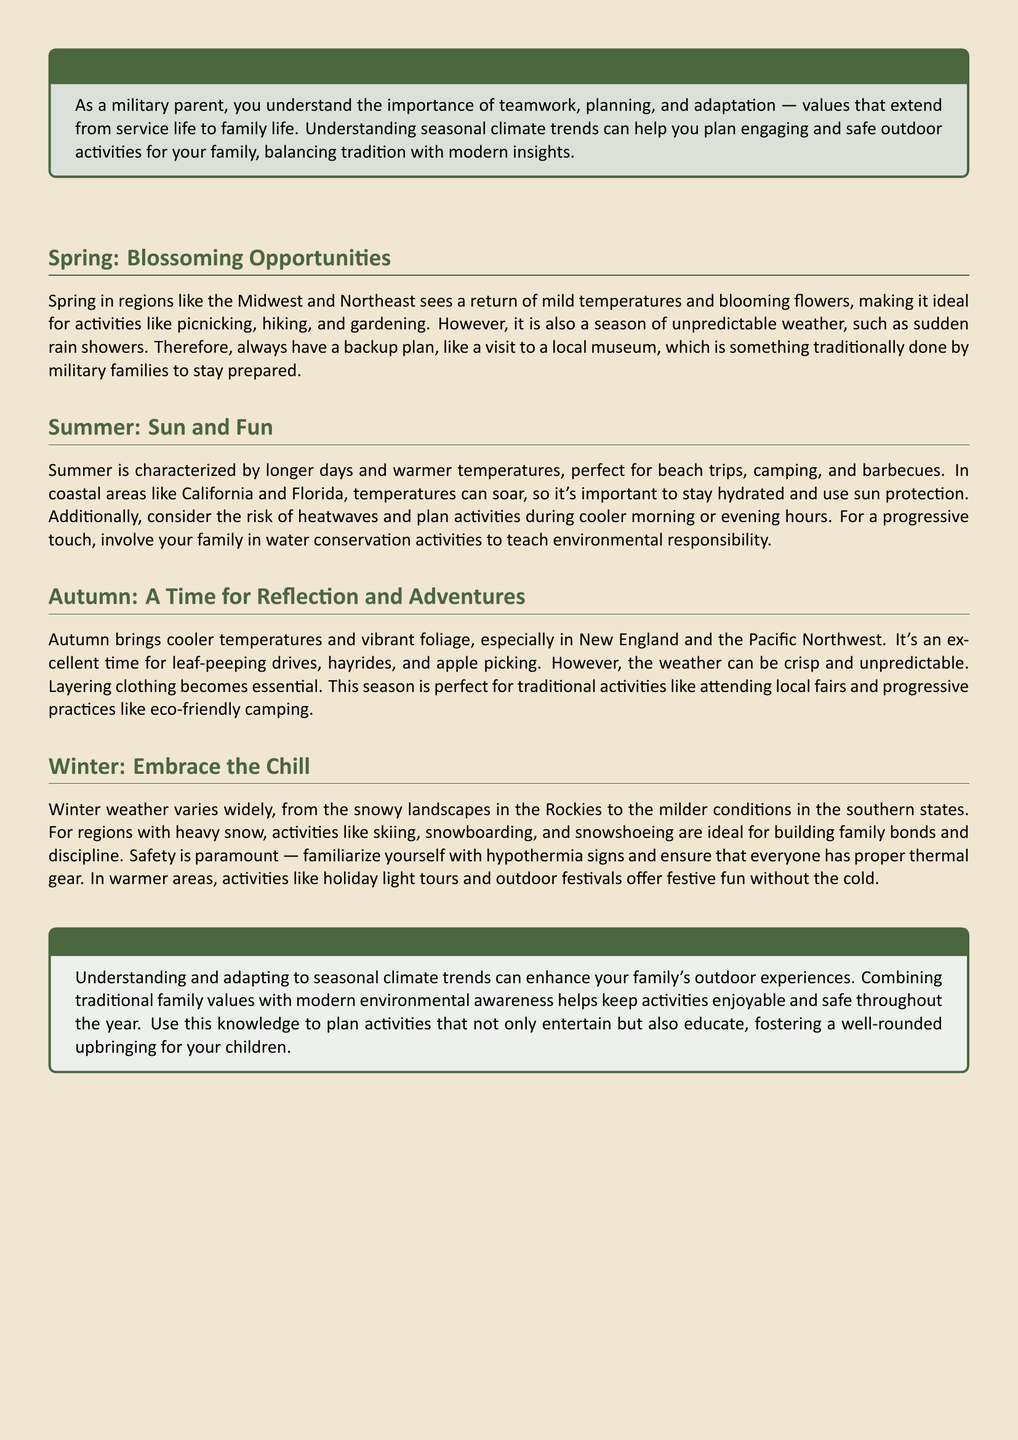What season is ideal for gardening? The document states that spring is ideal for gardening due to mild temperatures and blooming flowers.
Answer: Spring What should you always have during unpredictable weather in spring? A backup plan is advised for dealing with unpredictable spring weather, such as a visit to a local museum.
Answer: Backup plan What outdoor activities are recommended for summer? The document suggests beach trips, camping, and barbecues as recommended outdoor activities for summer.
Answer: Beach trips, camping, barbecues What is essential clothing during autumn? The document emphasizes the importance of layering clothing during the crisp and unpredictable autumn weather.
Answer: Layering clothing What are some recommended activities for winter in regions with heavy snow? Skiing, snowboarding, and snowshoeing are recommended activities for winter in snowy regions.
Answer: Skiing, snowboarding, snowshoeing What value does understanding seasonal climate trends enhance? The document mentions that understanding seasonal climate trends enhances your family's outdoor experiences.
Answer: Outdoor experiences What proactive environmental activity can families engage in during summer? The document suggests involving the family in water conservation activities as a proactive step during summer.
Answer: Water conservation activities What is highlighted as paramount for winter activities? Safety is emphasized as paramount for winter activities, particularly regarding hypothermia signs and proper thermal gear.
Answer: Safety How does the document suggest blending traditional activities with modern practices in autumn? The document suggests combining traditional activities like local fairs with progressive practices like eco-friendly camping in autumn.
Answer: Local fairs, eco-friendly camping 